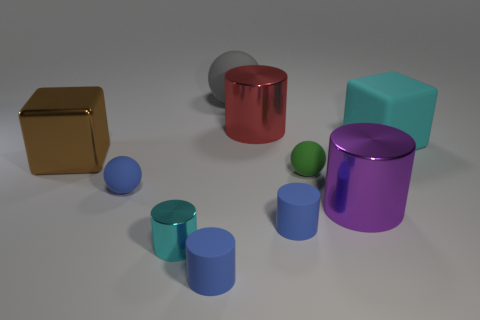Subtract 1 cylinders. How many cylinders are left? 4 Subtract all large red metallic cylinders. How many cylinders are left? 4 Subtract all cyan cylinders. How many cylinders are left? 4 Subtract all brown cylinders. Subtract all brown balls. How many cylinders are left? 5 Subtract all balls. How many objects are left? 7 Subtract all cyan shiny cylinders. Subtract all large metal objects. How many objects are left? 6 Add 3 cyan objects. How many cyan objects are left? 5 Add 1 tiny brown cylinders. How many tiny brown cylinders exist? 1 Subtract 0 purple cubes. How many objects are left? 10 